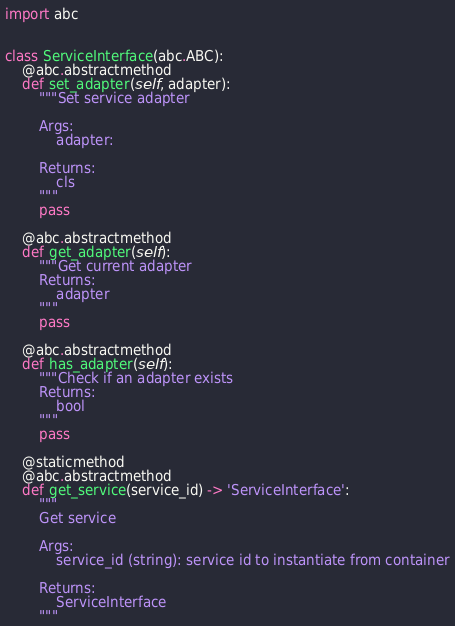Convert code to text. <code><loc_0><loc_0><loc_500><loc_500><_Python_>import abc


class ServiceInterface(abc.ABC):
    @abc.abstractmethod
    def set_adapter(self, adapter):
        """Set service adapter

        Args:
            adapter:

        Returns:
            cls
        """
        pass

    @abc.abstractmethod
    def get_adapter(self):
        """Get current adapter
        Returns:
            adapter
        """
        pass

    @abc.abstractmethod
    def has_adapter(self):
        """Check if an adapter exists
        Returns:
            bool
        """
        pass

    @staticmethod
    @abc.abstractmethod
    def get_service(service_id) -> 'ServiceInterface':
        """
        Get service

        Args:
            service_id (string): service id to instantiate from container

        Returns:
            ServiceInterface
        """
</code> 